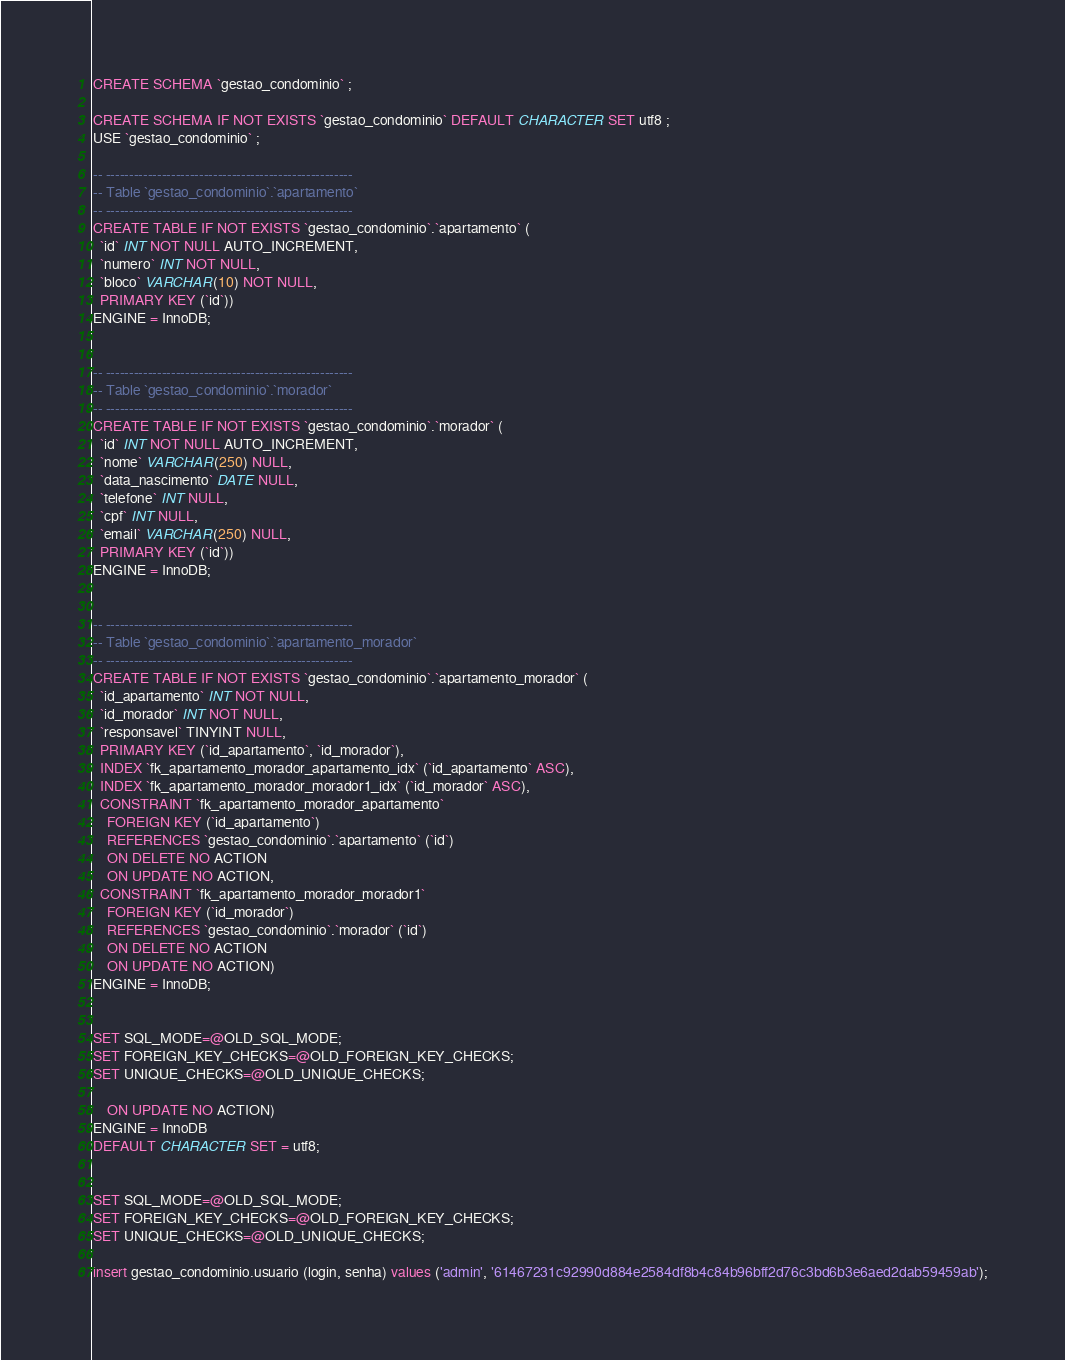Convert code to text. <code><loc_0><loc_0><loc_500><loc_500><_SQL_>CREATE SCHEMA `gestao_condominio` ;

CREATE SCHEMA IF NOT EXISTS `gestao_condominio` DEFAULT CHARACTER SET utf8 ;
USE `gestao_condominio` ;

-- -----------------------------------------------------
-- Table `gestao_condominio`.`apartamento`
-- -----------------------------------------------------
CREATE TABLE IF NOT EXISTS `gestao_condominio`.`apartamento` (
  `id` INT NOT NULL AUTO_INCREMENT,
  `numero` INT NOT NULL,
  `bloco` VARCHAR(10) NOT NULL,
  PRIMARY KEY (`id`))
ENGINE = InnoDB;


-- -----------------------------------------------------
-- Table `gestao_condominio`.`morador`
-- -----------------------------------------------------
CREATE TABLE IF NOT EXISTS `gestao_condominio`.`morador` (
  `id` INT NOT NULL AUTO_INCREMENT,
  `nome` VARCHAR(250) NULL,
  `data_nascimento` DATE NULL,
  `telefone` INT NULL,
  `cpf` INT NULL,
  `email` VARCHAR(250) NULL,
  PRIMARY KEY (`id`))
ENGINE = InnoDB;


-- -----------------------------------------------------
-- Table `gestao_condominio`.`apartamento_morador`
-- -----------------------------------------------------
CREATE TABLE IF NOT EXISTS `gestao_condominio`.`apartamento_morador` (
  `id_apartamento` INT NOT NULL,
  `id_morador` INT NOT NULL,
  `responsavel` TINYINT NULL,
  PRIMARY KEY (`id_apartamento`, `id_morador`),
  INDEX `fk_apartamento_morador_apartamento_idx` (`id_apartamento` ASC),
  INDEX `fk_apartamento_morador_morador1_idx` (`id_morador` ASC),
  CONSTRAINT `fk_apartamento_morador_apartamento`
    FOREIGN KEY (`id_apartamento`)
    REFERENCES `gestao_condominio`.`apartamento` (`id`)
    ON DELETE NO ACTION
    ON UPDATE NO ACTION,
  CONSTRAINT `fk_apartamento_morador_morador1`
    FOREIGN KEY (`id_morador`)
    REFERENCES `gestao_condominio`.`morador` (`id`)
    ON DELETE NO ACTION
    ON UPDATE NO ACTION)
ENGINE = InnoDB;


SET SQL_MODE=@OLD_SQL_MODE;
SET FOREIGN_KEY_CHECKS=@OLD_FOREIGN_KEY_CHECKS;
SET UNIQUE_CHECKS=@OLD_UNIQUE_CHECKS;

    ON UPDATE NO ACTION)
ENGINE = InnoDB
DEFAULT CHARACTER SET = utf8;


SET SQL_MODE=@OLD_SQL_MODE;
SET FOREIGN_KEY_CHECKS=@OLD_FOREIGN_KEY_CHECKS;
SET UNIQUE_CHECKS=@OLD_UNIQUE_CHECKS;

insert gestao_condominio.usuario (login, senha) values ('admin', '61467231c92990d884e2584df8b4c84b96bff2d76c3bd6b3e6aed2dab59459ab');
</code> 